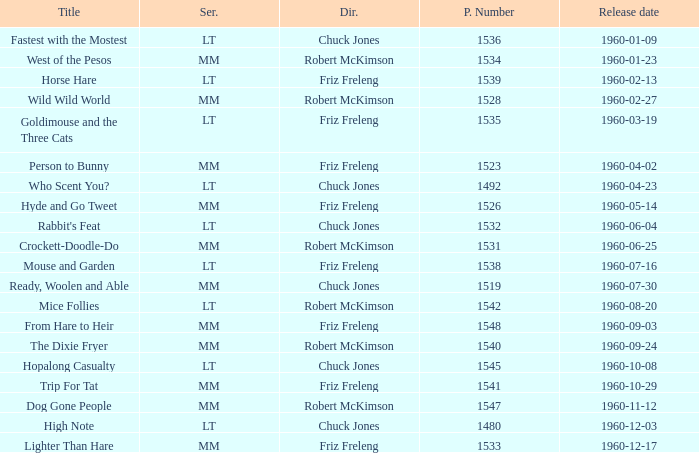What is the production number for the episode directed by Robert McKimson named Mice Follies? 1.0. 